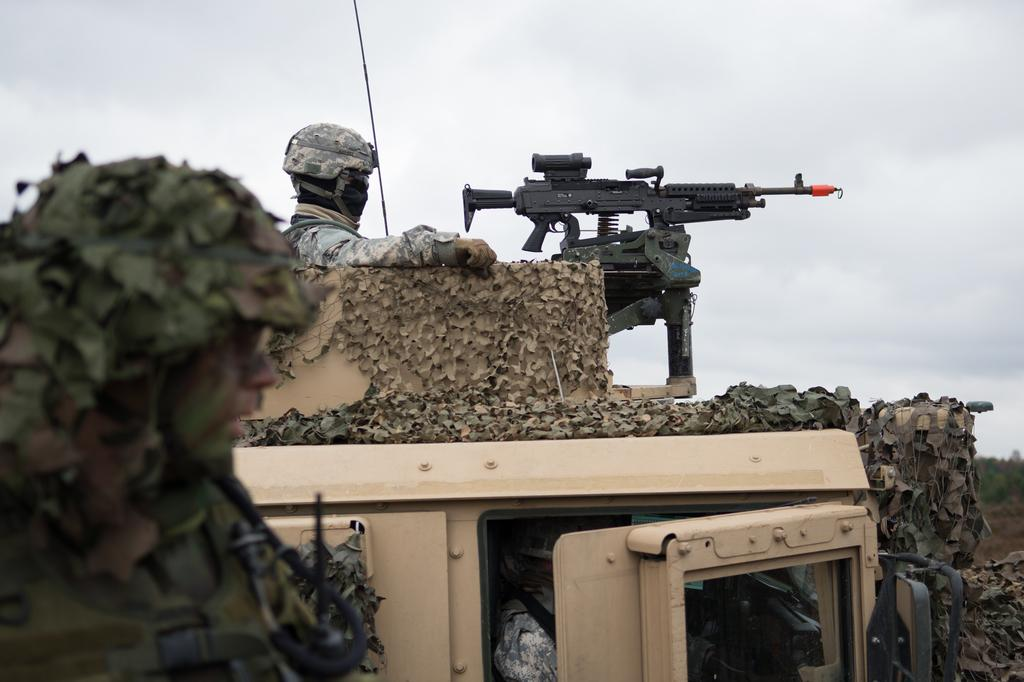How many people are in the image? There are two people in the image. What is present in the vehicle in the image? There is a gun in the vehicle. Can you describe the vehicle in the image? The vehicle is present in the image. What type of natural environment can be seen in the image? Trees are visible in the image. What is visible in the background of the image? The sky is visible in the image, and it appears to be cloudy. What is the person in the foreground of the image wearing? The person in the foreground of the image is wearing a helmet. How does the group of people shake the quiver in the image? There is no group of people shaking a quiver in the image; it only features two people and a vehicle with a gun. 